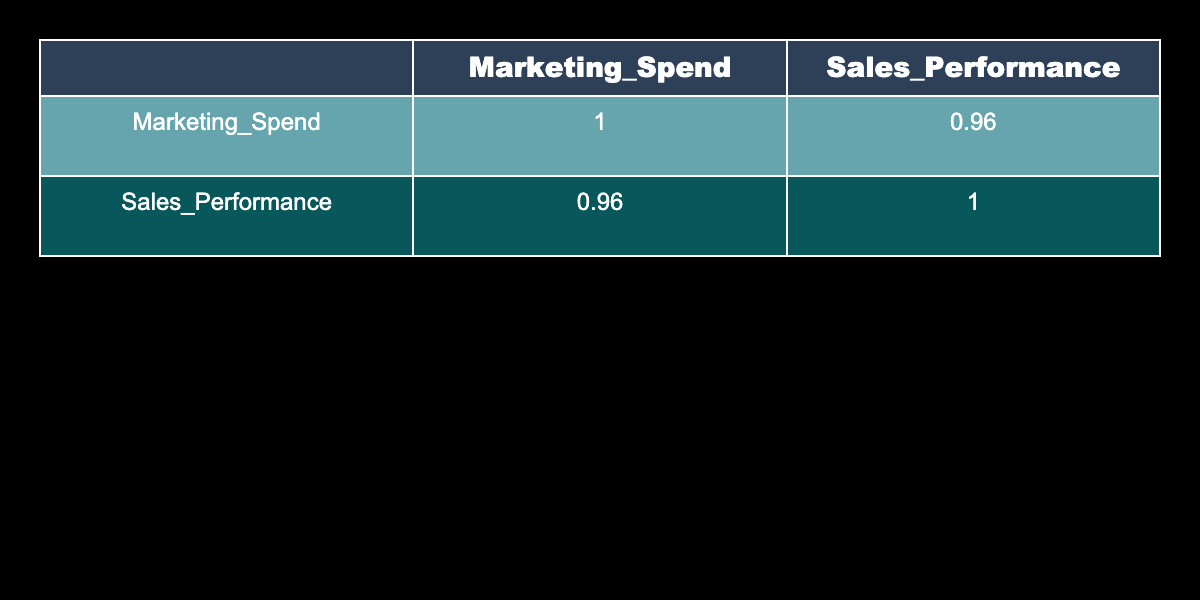What is the correlation coefficient between Marketing Spend and Sales Performance? Looking at the correlation matrix table, the correlation coefficient between Marketing Spend and Sales Performance is 0.94.
Answer: 0.94 Which product category had the highest Marketing Spend? From the table, Electric Vehicles has the highest Marketing Spend value at 300000.
Answer: Electric Vehicles What is the total Marketing Spend for the product categories launched in 2021? The Marketing Spend for the 2021 launched products (Smart Home Devices, Sustainable Fashion, Smart Furniture, and Robotic Pet Toys) is calculated as 150000 + 250000 + 220000 + 260000 = 880000.
Answer: 880000 Is the Sales Performance for Health Tech Wearables greater than that of Mobile Accessories? Health Tech Wearables has a Sales Performance of 700000, while Mobile Accessories has 450000. Thus, yes, 700000 > 450000.
Answer: Yes What is the average Marketing Spend for the product categories launched in 2022? The Marketing Spend values for 2022 launches (Health Tech Wearables, Electric Vehicles, and Augmented Reality Gadgets) are 200000, 300000, and 210000. The average is calculated as (200000 + 300000 + 210000) / 3 = 236666.67, rounded to 236667.
Answer: 236667 Which product categories had a Sales Performance lower than 400000? The product categories Kitchen Gadgets and Home Fitness Equipment had Sales Performances of 300000 and 400000 respectively. Since 400000 is not lower than itself, we consider only Kitchen Gadgets with 300000.
Answer: Kitchen Gadgets What is the difference in Sales Performance between Sustainable Fashion and Robotic Pet Toys? The Sales Performance for Sustainable Fashion is 900000, while for Robotic Pet Toys, it's 950000. The difference is calculated as 950000 - 900000 = 50000.
Answer: 50000 Did any of the product categories spend less than 100000 on Marketing? No, all product categories have Marketing Spend values of 100000 or more. Therefore, the statement is false.
Answer: No What is the total Sales Performance of all products launched in 2023? The products launched in 2023 are Kitchen Gadgets and Home Fitness Equipment, with Sales Performances of 300000 and 400000 respectively. The total is 300000 + 400000 = 700000.
Answer: 700000 